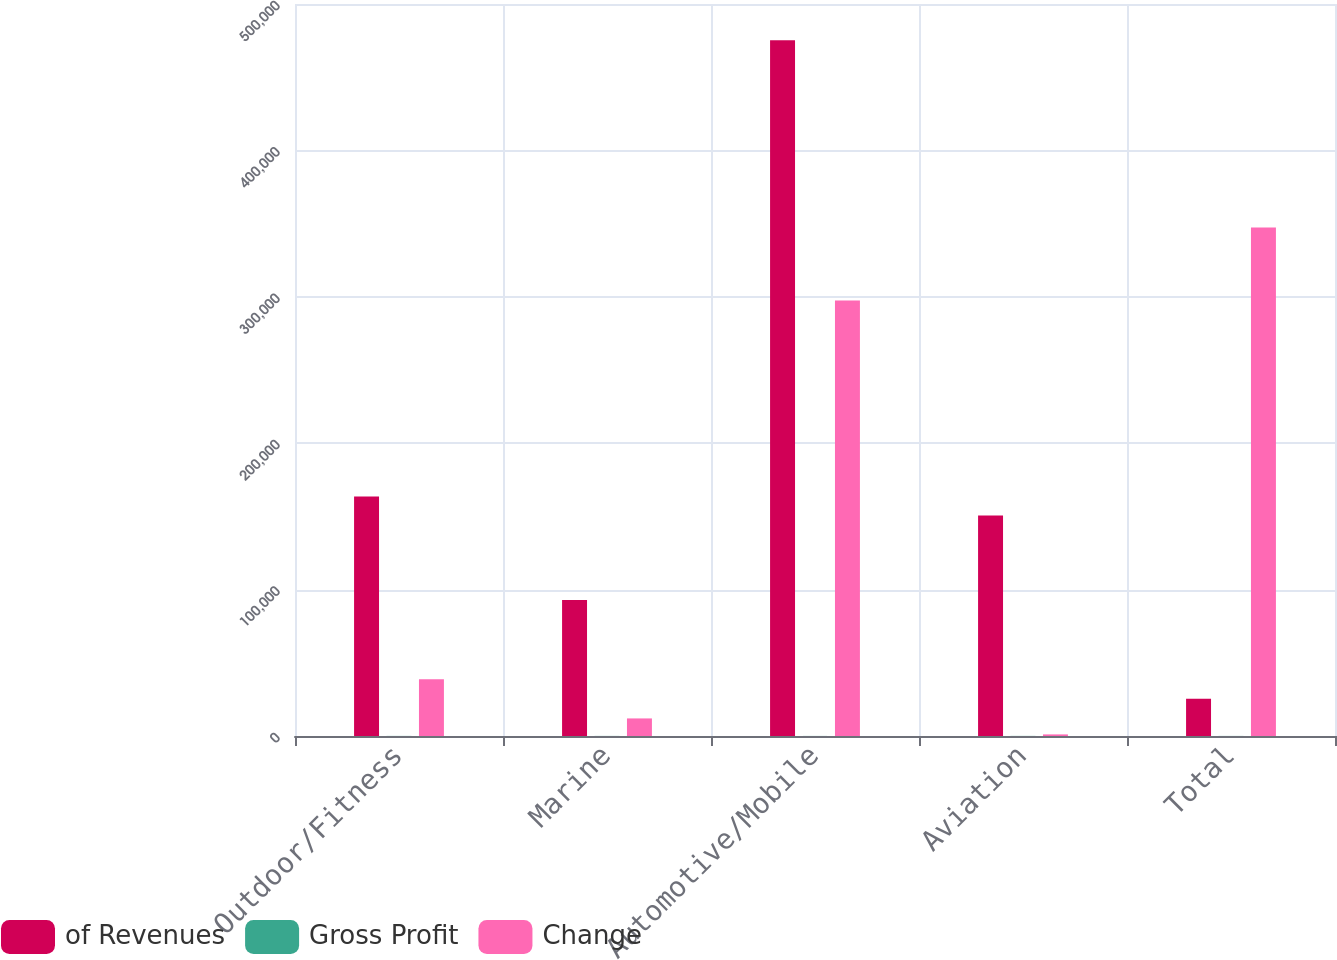Convert chart. <chart><loc_0><loc_0><loc_500><loc_500><stacked_bar_chart><ecel><fcel>Outdoor/Fitness<fcel>Marine<fcel>Automotive/Mobile<fcel>Aviation<fcel>Total<nl><fcel>of Revenues<fcel>163638<fcel>92952<fcel>475191<fcel>150605<fcel>25424<nl><fcel>Gross Profit<fcel>57.3<fcel>55.8<fcel>43.6<fcel>64.7<fcel>49.7<nl><fcel>Change<fcel>38847<fcel>12001<fcel>297553<fcel>1085<fcel>347316<nl></chart> 